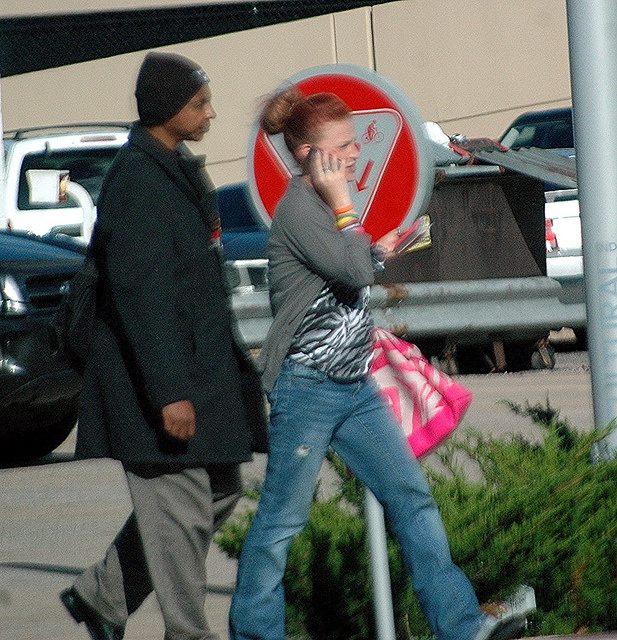Describe the objects in this image and their specific colors. I can see people in darkgray, black, gray, and maroon tones, people in darkgray, blue, gray, and black tones, stop sign in darkgray and brown tones, car in darkgray, black, blue, darkblue, and gray tones, and car in darkgray, white, black, and gray tones in this image. 